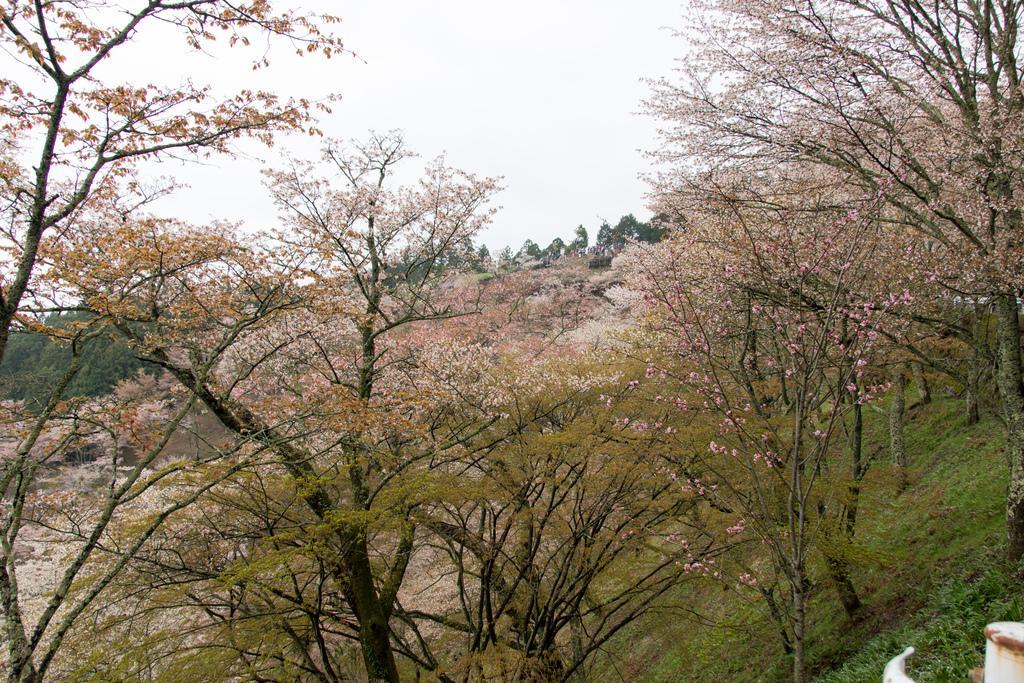How would you summarize this image in a sentence or two? In the center of the image there are trees. At the top there is sky. 